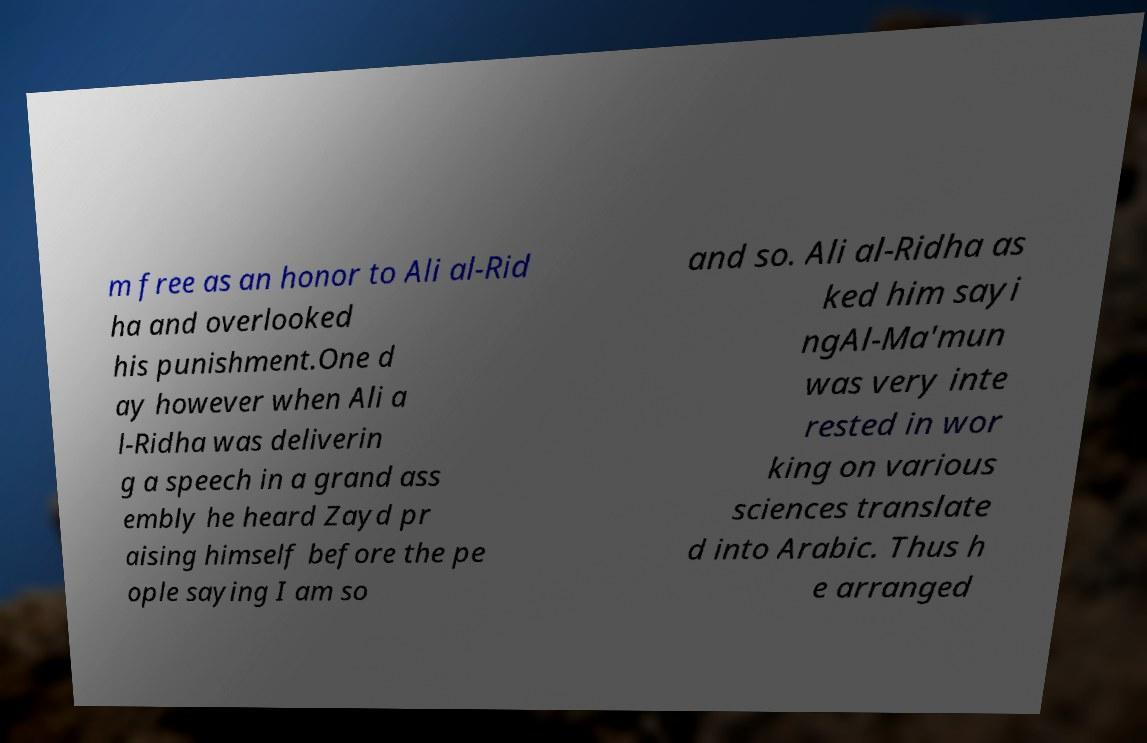There's text embedded in this image that I need extracted. Can you transcribe it verbatim? m free as an honor to Ali al-Rid ha and overlooked his punishment.One d ay however when Ali a l-Ridha was deliverin g a speech in a grand ass embly he heard Zayd pr aising himself before the pe ople saying I am so and so. Ali al-Ridha as ked him sayi ngAl-Ma'mun was very inte rested in wor king on various sciences translate d into Arabic. Thus h e arranged 